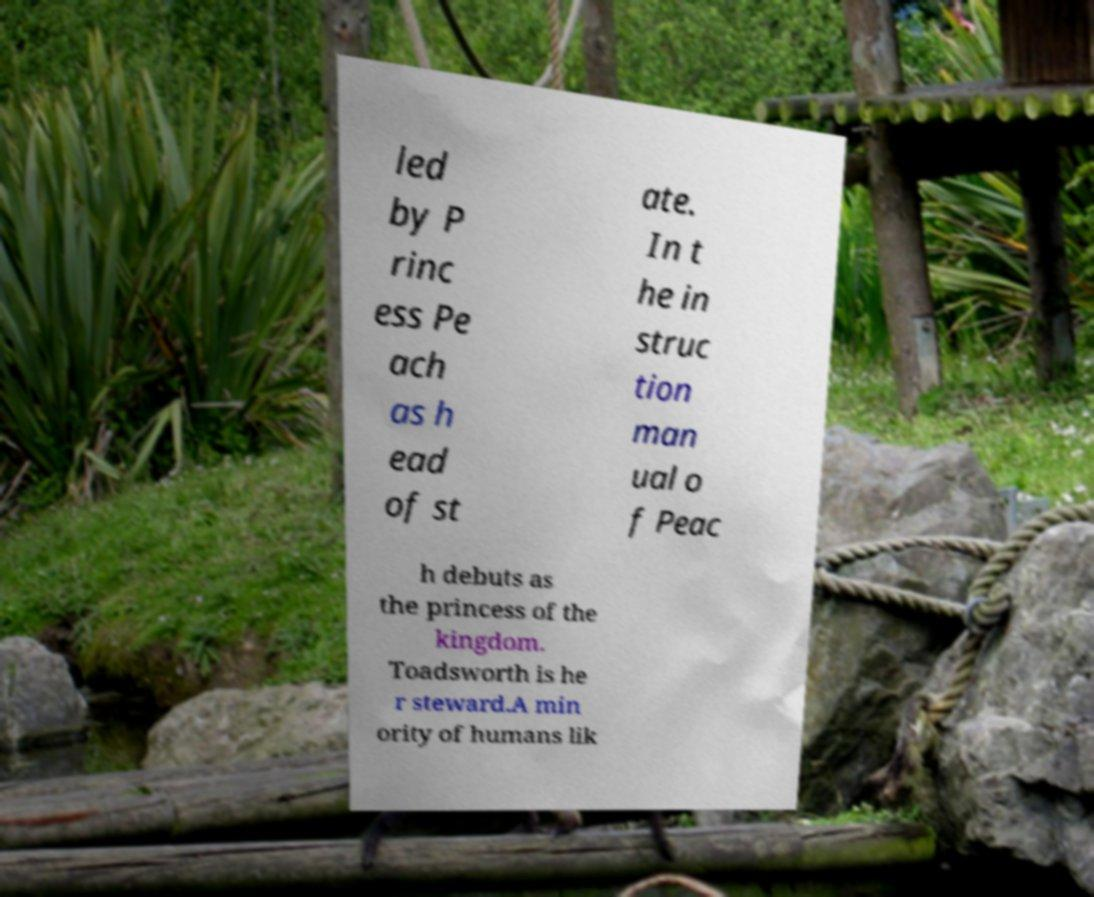Can you accurately transcribe the text from the provided image for me? led by P rinc ess Pe ach as h ead of st ate. In t he in struc tion man ual o f Peac h debuts as the princess of the kingdom. Toadsworth is he r steward.A min ority of humans lik 